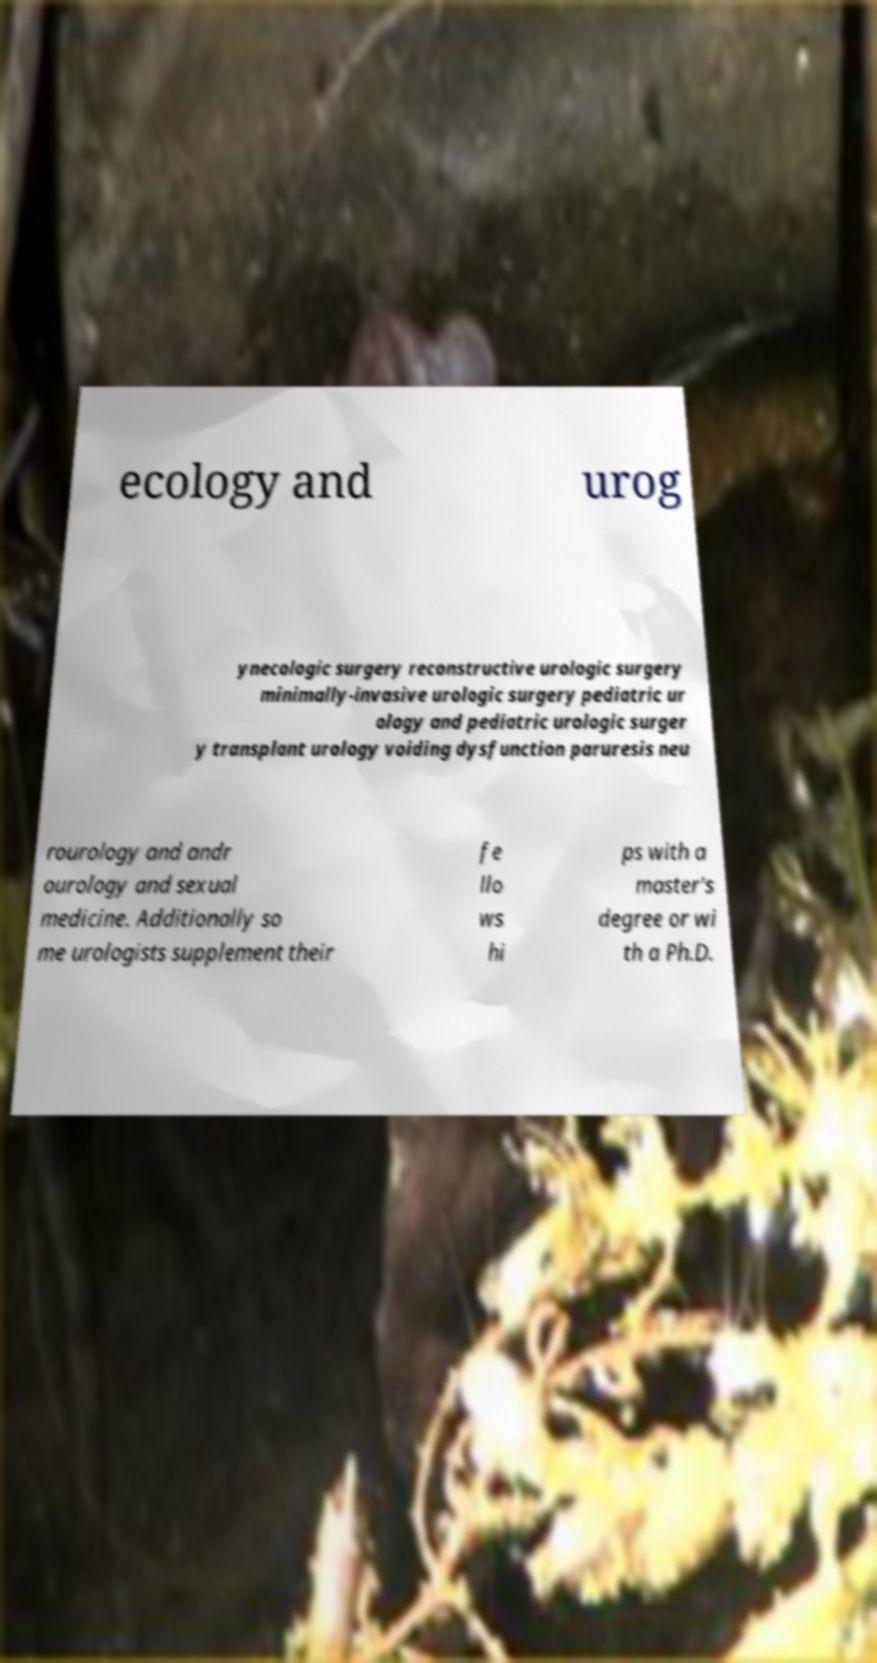Can you accurately transcribe the text from the provided image for me? ecology and urog ynecologic surgery reconstructive urologic surgery minimally-invasive urologic surgery pediatric ur ology and pediatric urologic surger y transplant urology voiding dysfunction paruresis neu rourology and andr ourology and sexual medicine. Additionally so me urologists supplement their fe llo ws hi ps with a master's degree or wi th a Ph.D. 